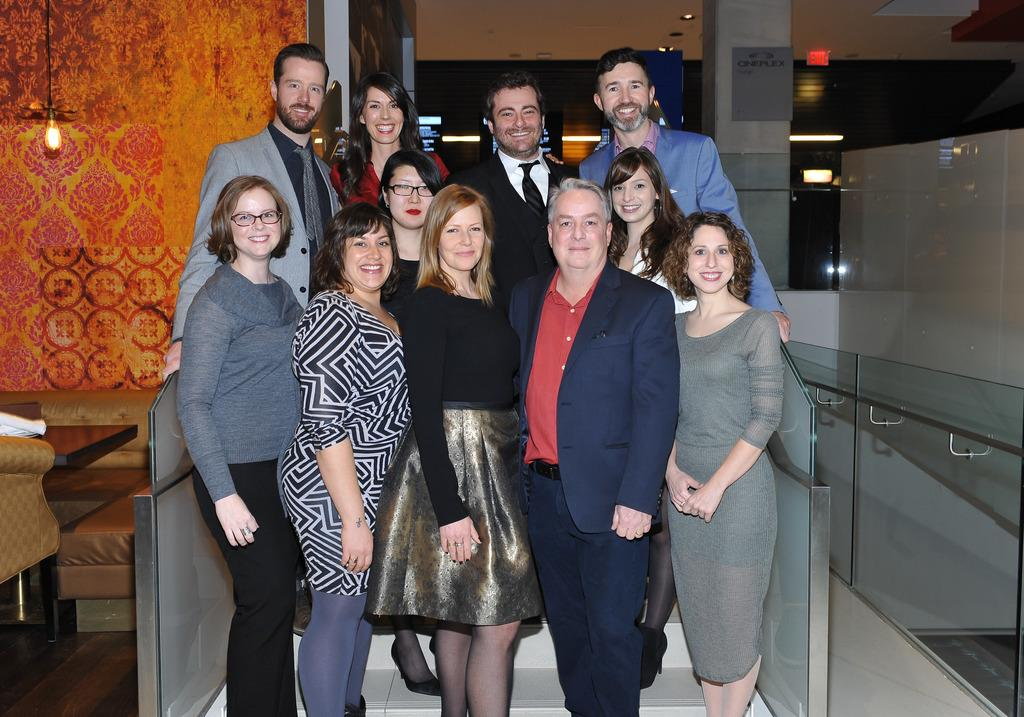What is happening in the image? There are people standing in the image. Can you describe the light in the image? There is a light in the image. What type of robin can be seen singing near the light in the image? There is no robin present in the image. What phase of the moon can be seen in the image? The image does not show the moon; it only shows people standing and a light. 